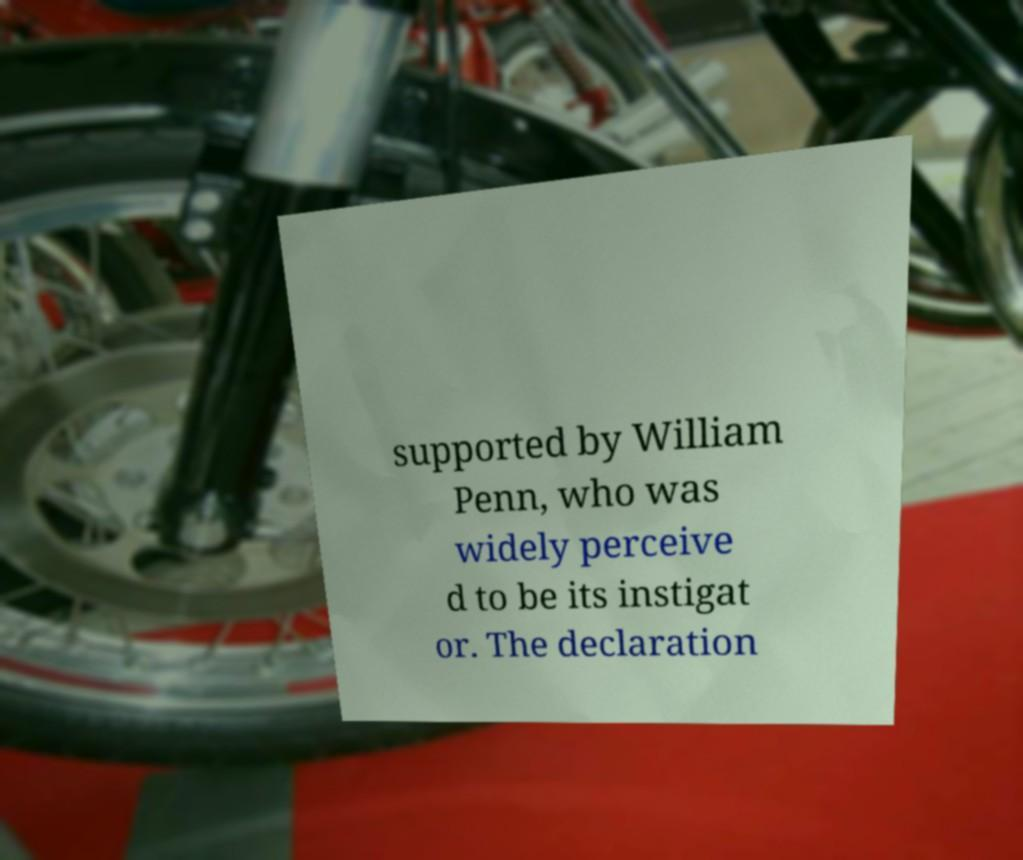Can you read and provide the text displayed in the image?This photo seems to have some interesting text. Can you extract and type it out for me? supported by William Penn, who was widely perceive d to be its instigat or. The declaration 